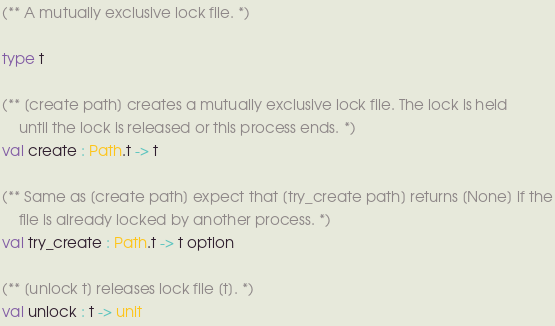<code> <loc_0><loc_0><loc_500><loc_500><_OCaml_>(** A mutually exclusive lock file. *)

type t

(** [create path] creates a mutually exclusive lock file. The lock is held
    until the lock is released or this process ends. *)
val create : Path.t -> t

(** Same as [create path] expect that [try_create path] returns [None] if the
    file is already locked by another process. *)
val try_create : Path.t -> t option

(** [unlock t] releases lock file [t]. *)
val unlock : t -> unit
</code> 